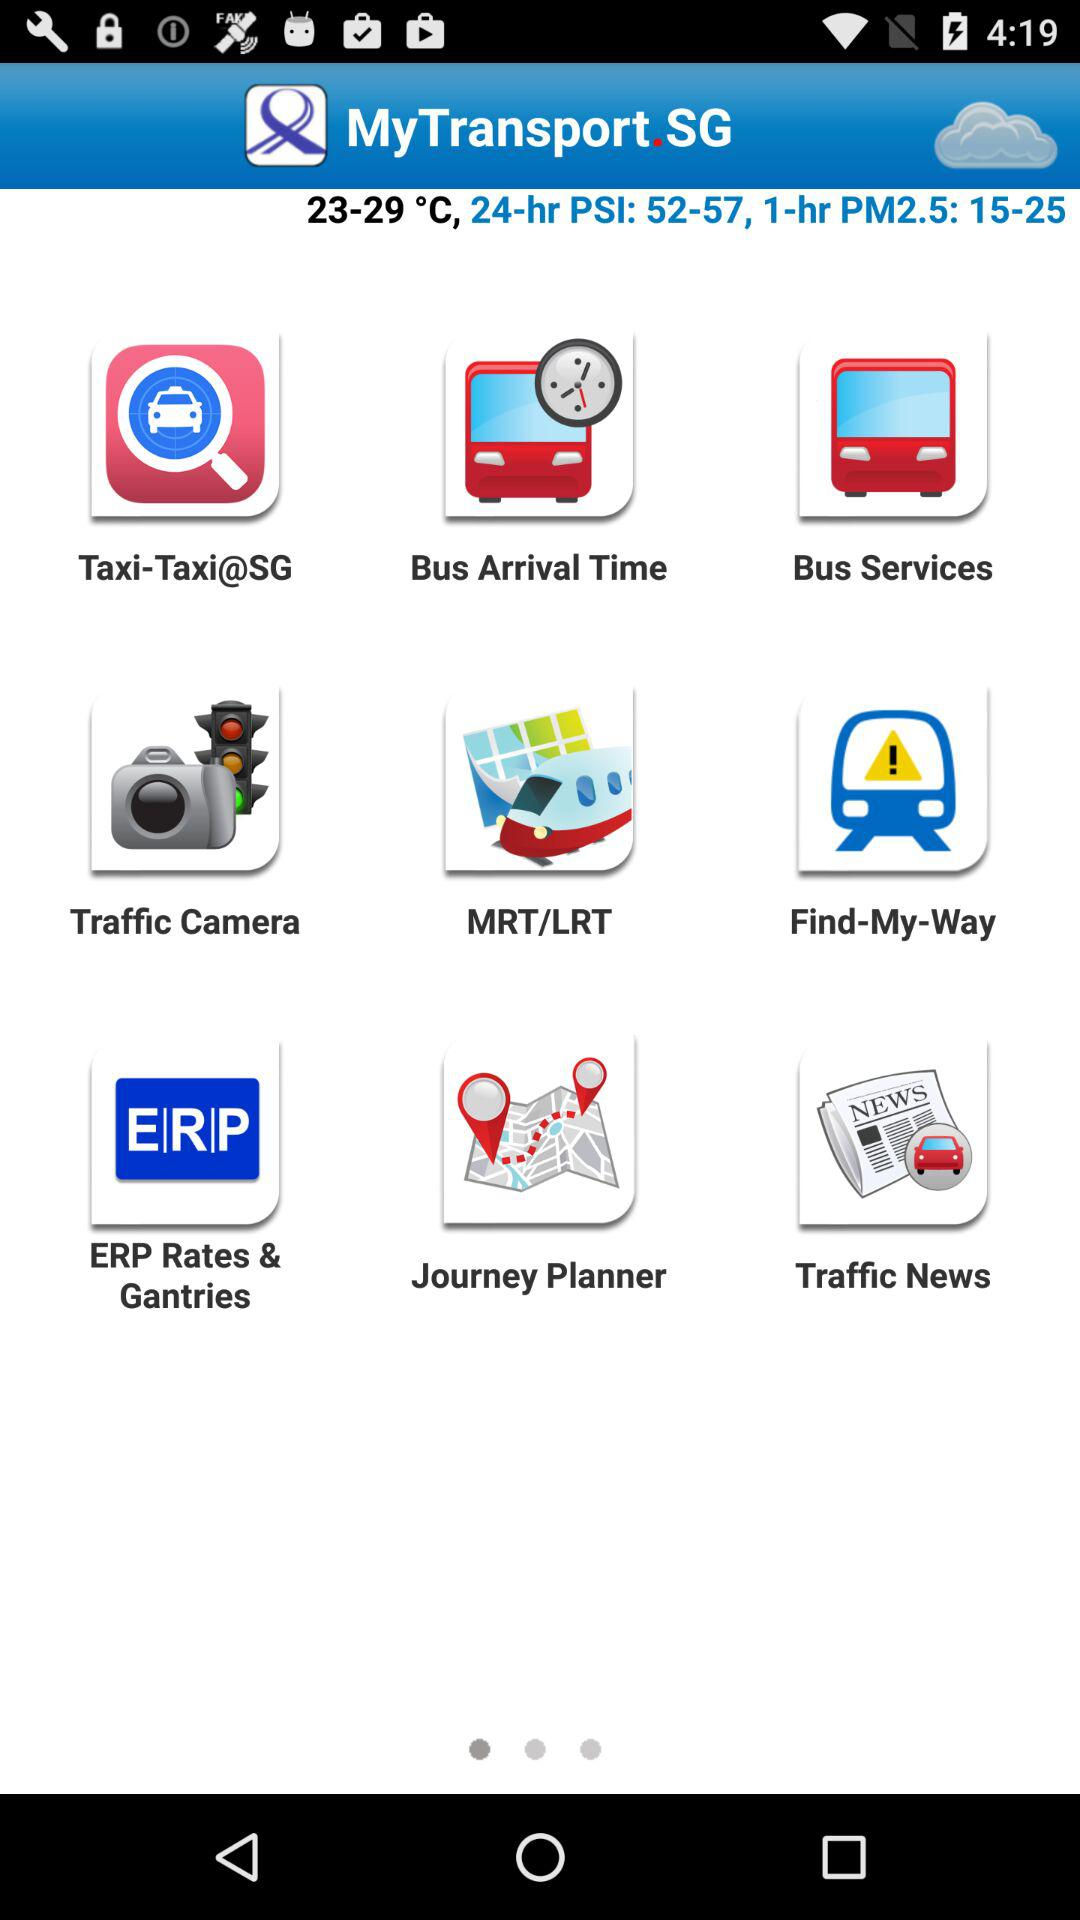What's the 24-hr PSI value? The 24-hour PSI value ranges from 52 to 57. 